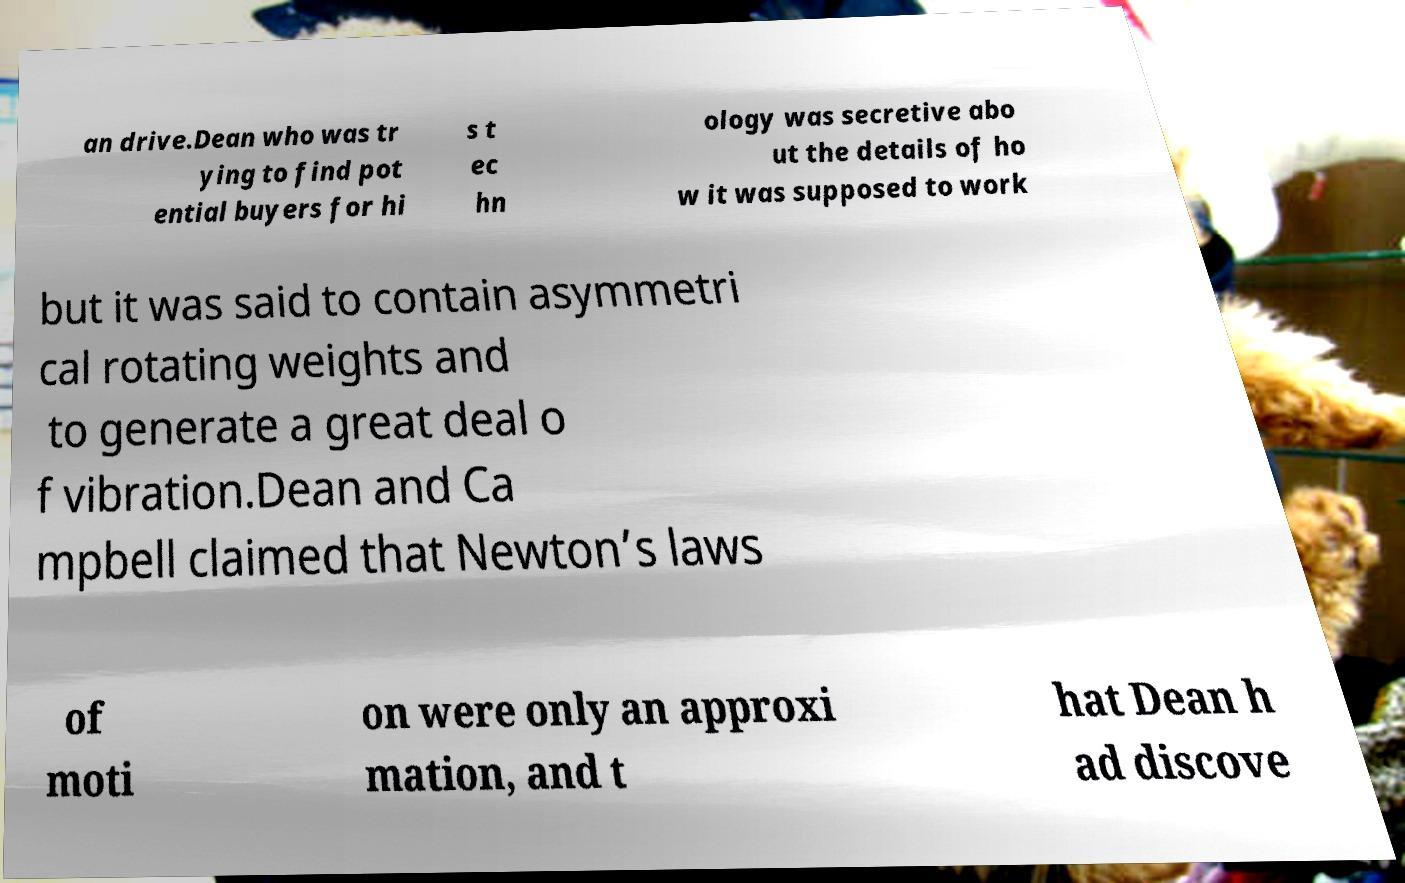I need the written content from this picture converted into text. Can you do that? an drive.Dean who was tr ying to find pot ential buyers for hi s t ec hn ology was secretive abo ut the details of ho w it was supposed to work but it was said to contain asymmetri cal rotating weights and to generate a great deal o f vibration.Dean and Ca mpbell claimed that Newton’s laws of moti on were only an approxi mation, and t hat Dean h ad discove 